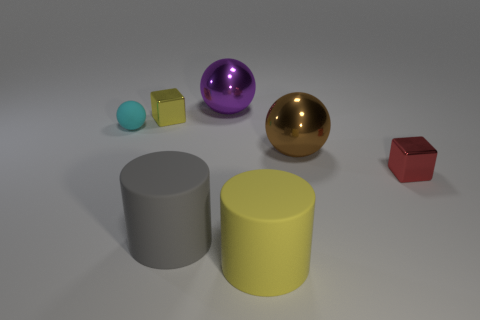Is there anything else that has the same color as the small ball?
Give a very brief answer. No. The other big object that is the same shape as the gray thing is what color?
Offer a terse response. Yellow. How big is the object that is to the left of the gray matte object and on the right side of the tiny cyan sphere?
Provide a succinct answer. Small. There is a yellow thing in front of the red shiny block; does it have the same shape as the small metal thing that is to the right of the large purple metal object?
Offer a very short reply. No. What number of yellow blocks have the same material as the small ball?
Offer a very short reply. 0. What shape is the large thing that is in front of the tiny yellow thing and on the left side of the yellow cylinder?
Give a very brief answer. Cylinder. Are the brown sphere that is in front of the yellow cube and the big purple ball made of the same material?
Provide a succinct answer. Yes. Is there anything else that has the same material as the tiny yellow block?
Ensure brevity in your answer.  Yes. What is the color of the rubber cylinder that is the same size as the gray thing?
Provide a short and direct response. Yellow. The yellow object that is made of the same material as the large gray object is what size?
Offer a very short reply. Large. 